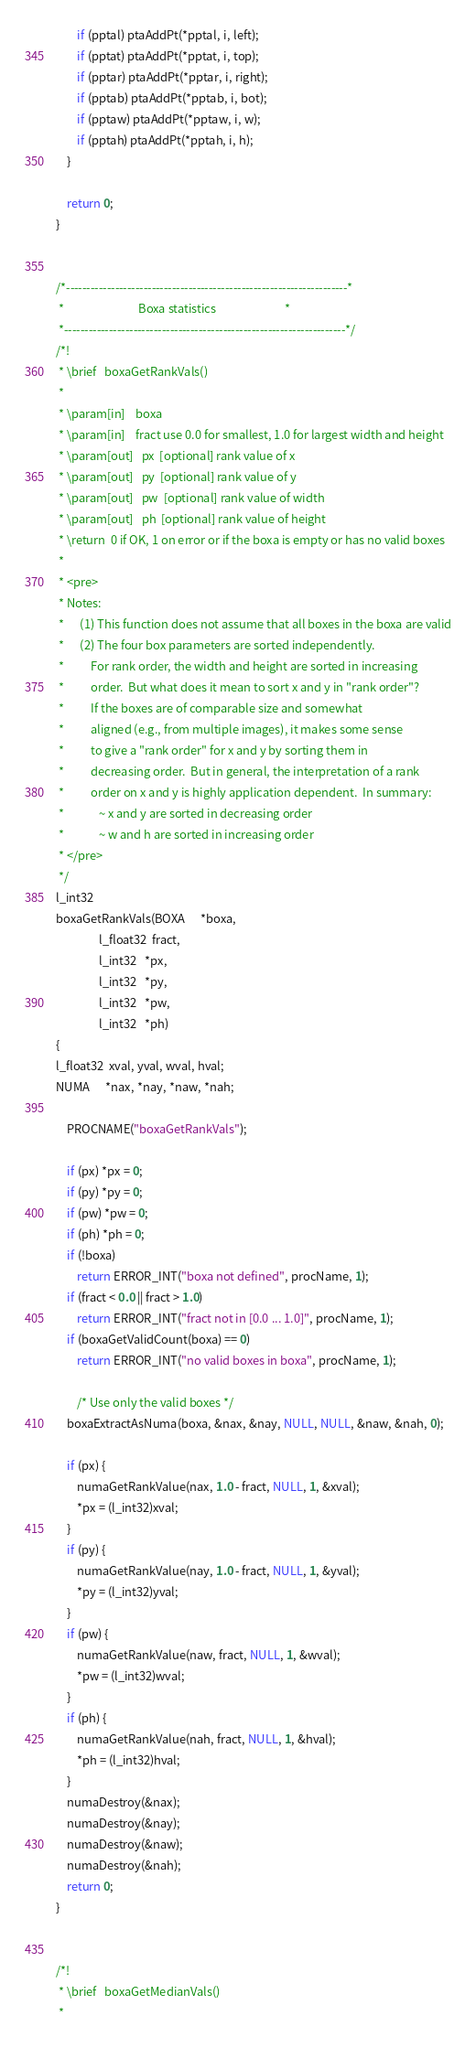<code> <loc_0><loc_0><loc_500><loc_500><_C_>        if (pptal) ptaAddPt(*pptal, i, left);
        if (pptat) ptaAddPt(*pptat, i, top);
        if (pptar) ptaAddPt(*pptar, i, right);
        if (pptab) ptaAddPt(*pptab, i, bot);
        if (pptaw) ptaAddPt(*pptaw, i, w);
        if (pptah) ptaAddPt(*pptah, i, h);
    }

    return 0;
}


/*---------------------------------------------------------------------*
 *                            Boxa statistics                          *
 *---------------------------------------------------------------------*/
/*!
 * \brief   boxaGetRankVals()
 *
 * \param[in]    boxa
 * \param[in]    fract use 0.0 for smallest, 1.0 for largest width and height
 * \param[out]   px  [optional] rank value of x
 * \param[out]   py  [optional] rank value of y
 * \param[out]   pw  [optional] rank value of width
 * \param[out]   ph  [optional] rank value of height
 * \return  0 if OK, 1 on error or if the boxa is empty or has no valid boxes
 *
 * <pre>
 * Notes:
 *      (1) This function does not assume that all boxes in the boxa are valid
 *      (2) The four box parameters are sorted independently.
 *          For rank order, the width and height are sorted in increasing
 *          order.  But what does it mean to sort x and y in "rank order"?
 *          If the boxes are of comparable size and somewhat
 *          aligned (e.g., from multiple images), it makes some sense
 *          to give a "rank order" for x and y by sorting them in
 *          decreasing order.  But in general, the interpretation of a rank
 *          order on x and y is highly application dependent.  In summary:
 *             ~ x and y are sorted in decreasing order
 *             ~ w and h are sorted in increasing order
 * </pre>
 */
l_int32
boxaGetRankVals(BOXA      *boxa,
                l_float32  fract,
                l_int32   *px,
                l_int32   *py,
                l_int32   *pw,
                l_int32   *ph)
{
l_float32  xval, yval, wval, hval;
NUMA      *nax, *nay, *naw, *nah;

    PROCNAME("boxaGetRankVals");

    if (px) *px = 0;
    if (py) *py = 0;
    if (pw) *pw = 0;
    if (ph) *ph = 0;
    if (!boxa)
        return ERROR_INT("boxa not defined", procName, 1);
    if (fract < 0.0 || fract > 1.0)
        return ERROR_INT("fract not in [0.0 ... 1.0]", procName, 1);
    if (boxaGetValidCount(boxa) == 0)
        return ERROR_INT("no valid boxes in boxa", procName, 1);

        /* Use only the valid boxes */
    boxaExtractAsNuma(boxa, &nax, &nay, NULL, NULL, &naw, &nah, 0);

    if (px) {
        numaGetRankValue(nax, 1.0 - fract, NULL, 1, &xval);
        *px = (l_int32)xval;
    }
    if (py) {
        numaGetRankValue(nay, 1.0 - fract, NULL, 1, &yval);
        *py = (l_int32)yval;
    }
    if (pw) {
        numaGetRankValue(naw, fract, NULL, 1, &wval);
        *pw = (l_int32)wval;
    }
    if (ph) {
        numaGetRankValue(nah, fract, NULL, 1, &hval);
        *ph = (l_int32)hval;
    }
    numaDestroy(&nax);
    numaDestroy(&nay);
    numaDestroy(&naw);
    numaDestroy(&nah);
    return 0;
}


/*!
 * \brief   boxaGetMedianVals()
 *</code> 